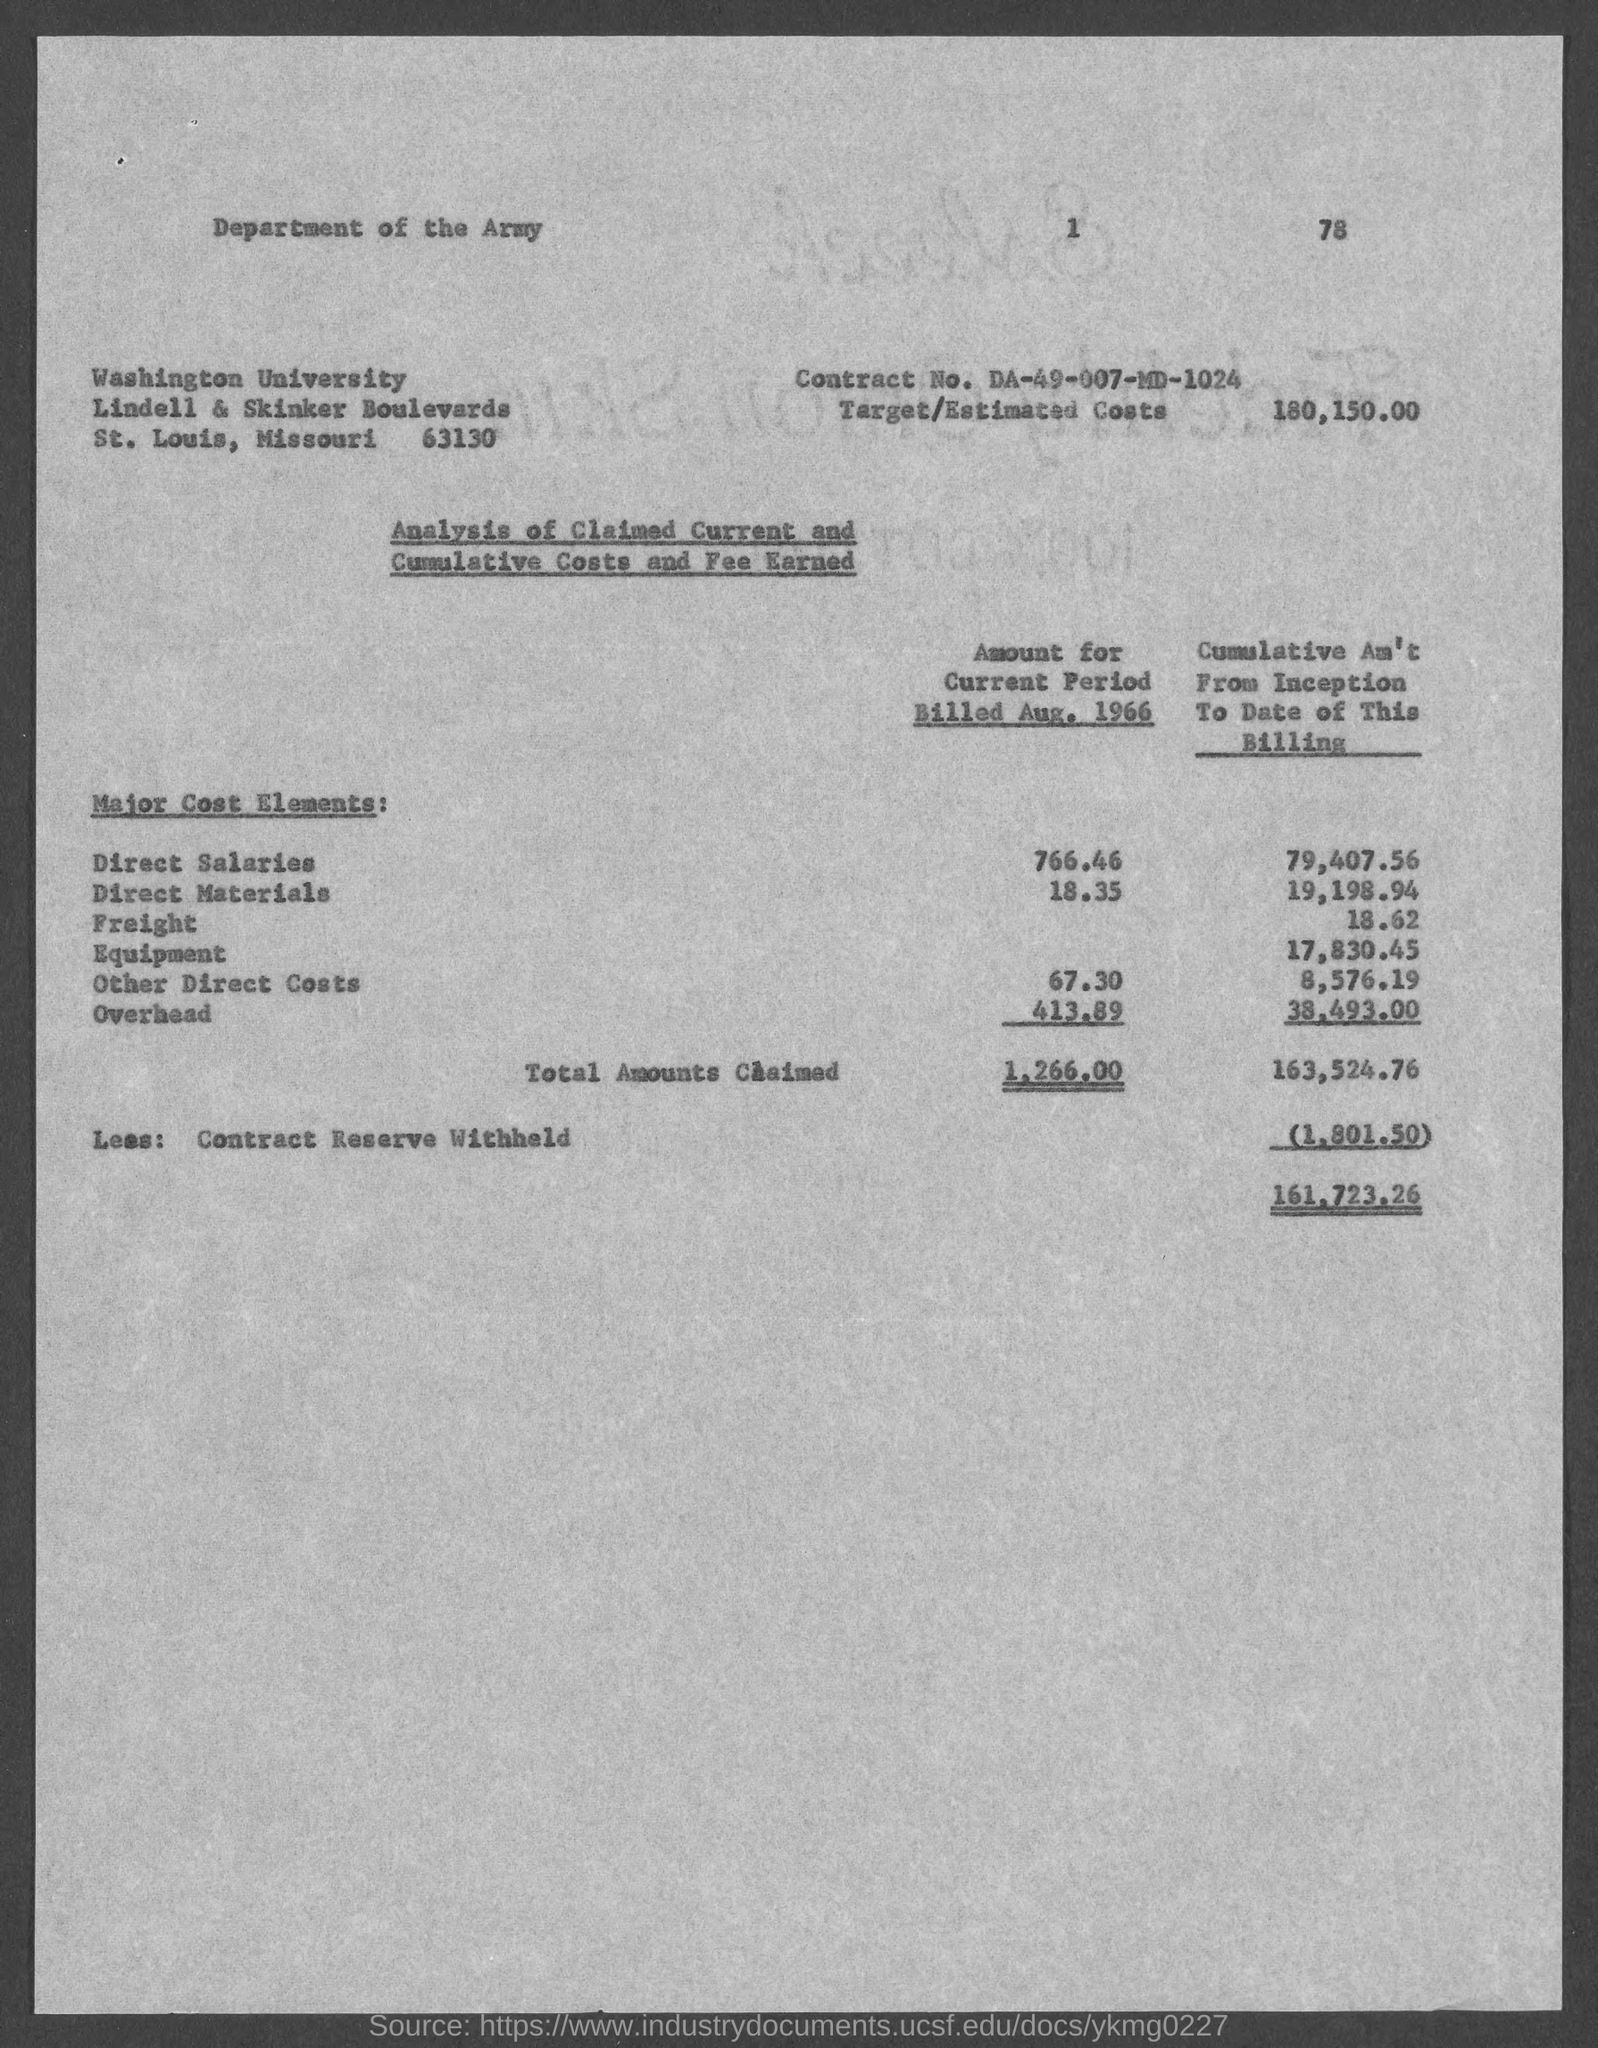What is the street address of washington university ?
Your answer should be compact. Lindell & Skinker Boulevards. What is the contract no. ?
Your answer should be very brief. DA-49-007-MD-1024. What is the target/estimated costs ?
Your answer should be very brief. 180,150.00. 